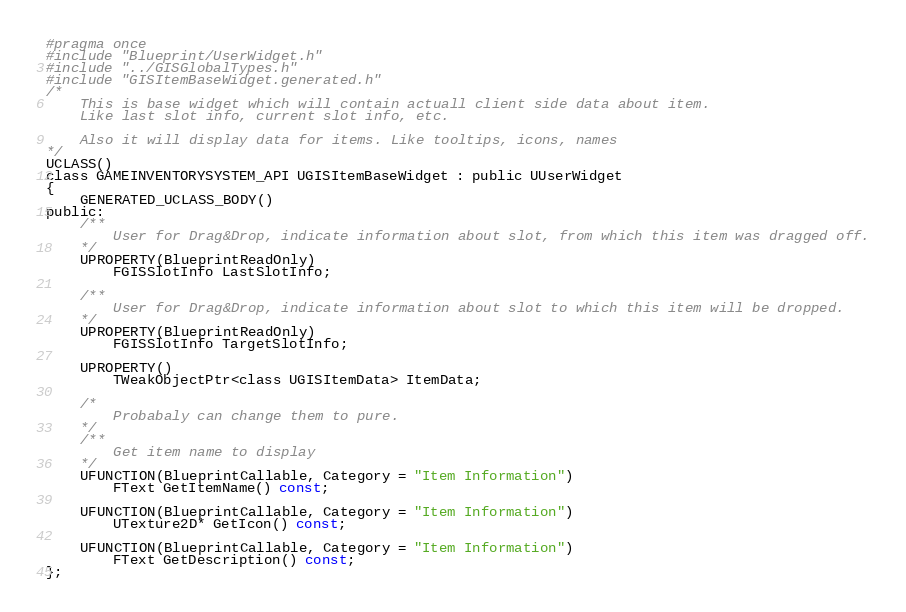<code> <loc_0><loc_0><loc_500><loc_500><_C_>#pragma once
#include "Blueprint/UserWidget.h"
#include "../GISGlobalTypes.h"
#include "GISItemBaseWidget.generated.h"
/*
	This is base widget which will contain actuall client side data about item.
	Like last slot info, current slot info, etc.

	Also it will display data for items. Like tooltips, icons, names
*/
UCLASS()
class GAMEINVENTORYSYSTEM_API UGISItemBaseWidget : public UUserWidget
{
	GENERATED_UCLASS_BODY()
public:
	/**
		User for Drag&Drop, indicate information about slot, from which this item was dragged off.
	*/
	UPROPERTY(BlueprintReadOnly)
		FGISSlotInfo LastSlotInfo;

	/**
		User for Drag&Drop, indicate information about slot to which this item will be dropped.
	*/
	UPROPERTY(BlueprintReadOnly)
		FGISSlotInfo TargetSlotInfo;

	UPROPERTY()
		TWeakObjectPtr<class UGISItemData> ItemData;

	/*
		Probabaly can change them to pure.	
	*/
	/**
		Get item name to display
	*/
	UFUNCTION(BlueprintCallable, Category = "Item Information")
		FText GetItemName() const;

	UFUNCTION(BlueprintCallable, Category = "Item Information")
		UTexture2D* GetIcon() const;

	UFUNCTION(BlueprintCallable, Category = "Item Information")
		FText GetDescription() const;
};
</code> 